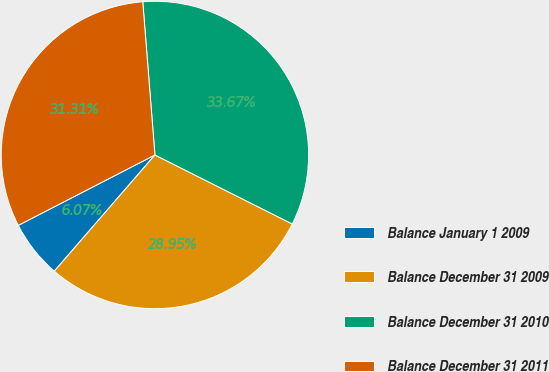Convert chart. <chart><loc_0><loc_0><loc_500><loc_500><pie_chart><fcel>Balance January 1 2009<fcel>Balance December 31 2009<fcel>Balance December 31 2010<fcel>Balance December 31 2011<nl><fcel>6.07%<fcel>28.95%<fcel>33.67%<fcel>31.31%<nl></chart> 